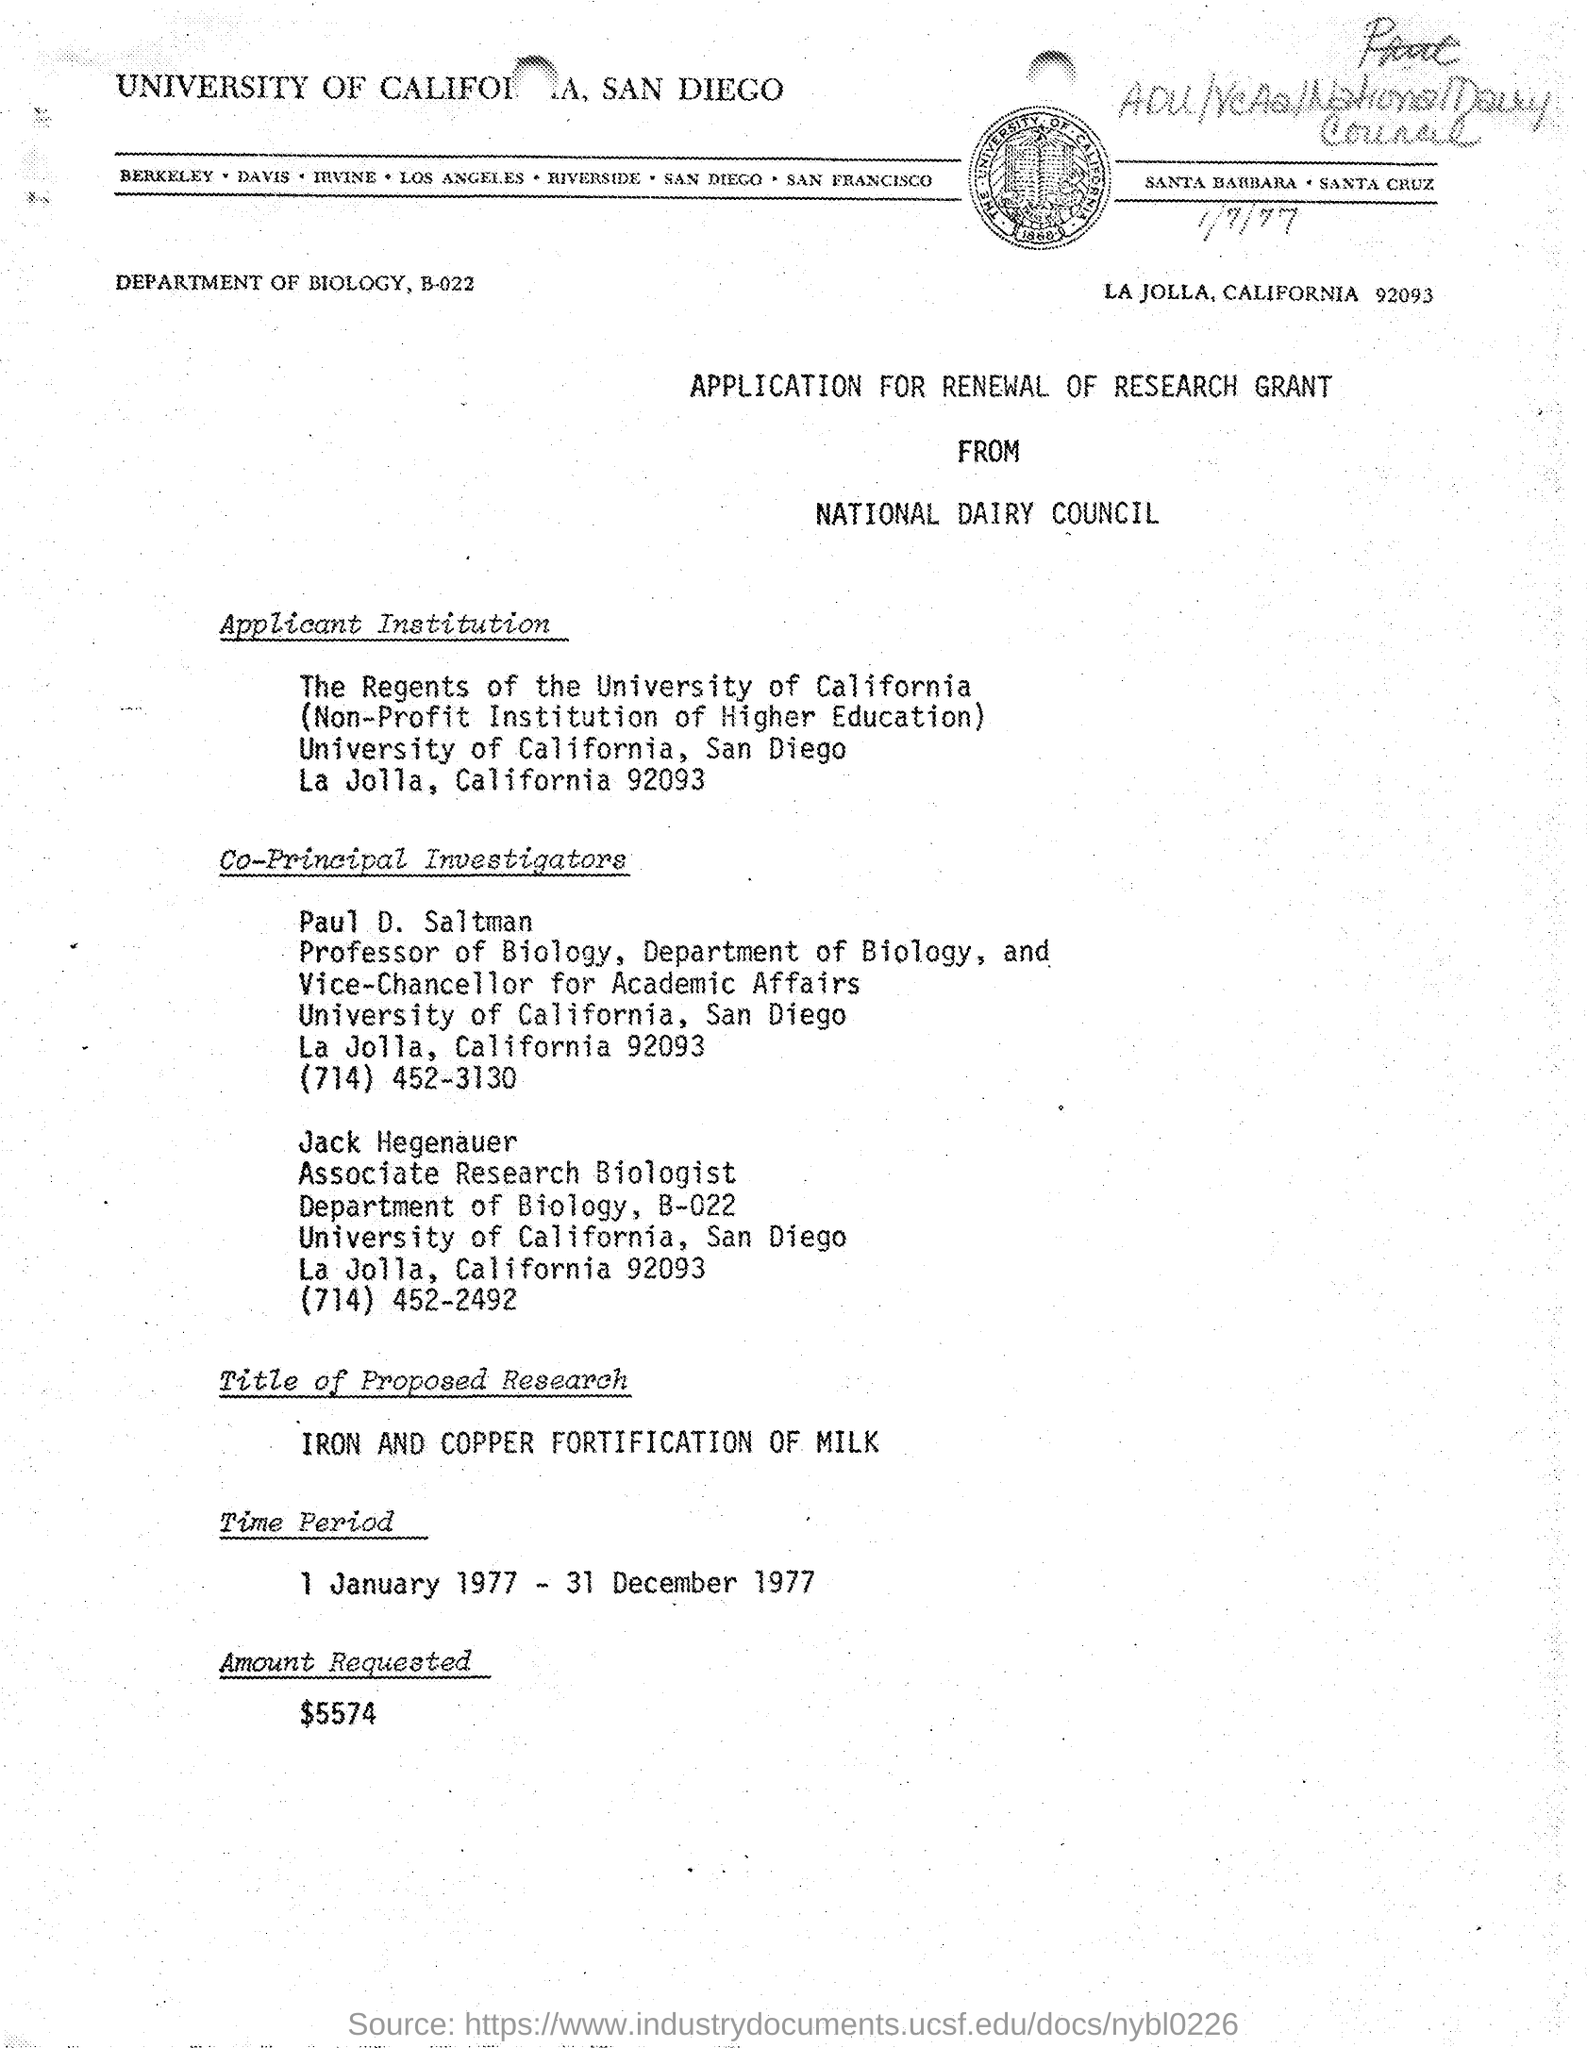Highlight a few significant elements in this photo. Jack Hegenauer is a student at the University of California. Paul D. Saltman belongs to the Department of Biology. The name of the application is "Application for Renewal of Research Grant. Jack Hegenauer is an associate research biologist with a designated title of "what is. The proposed project is titled 'Iron and Copper Fortification of Milk.' 